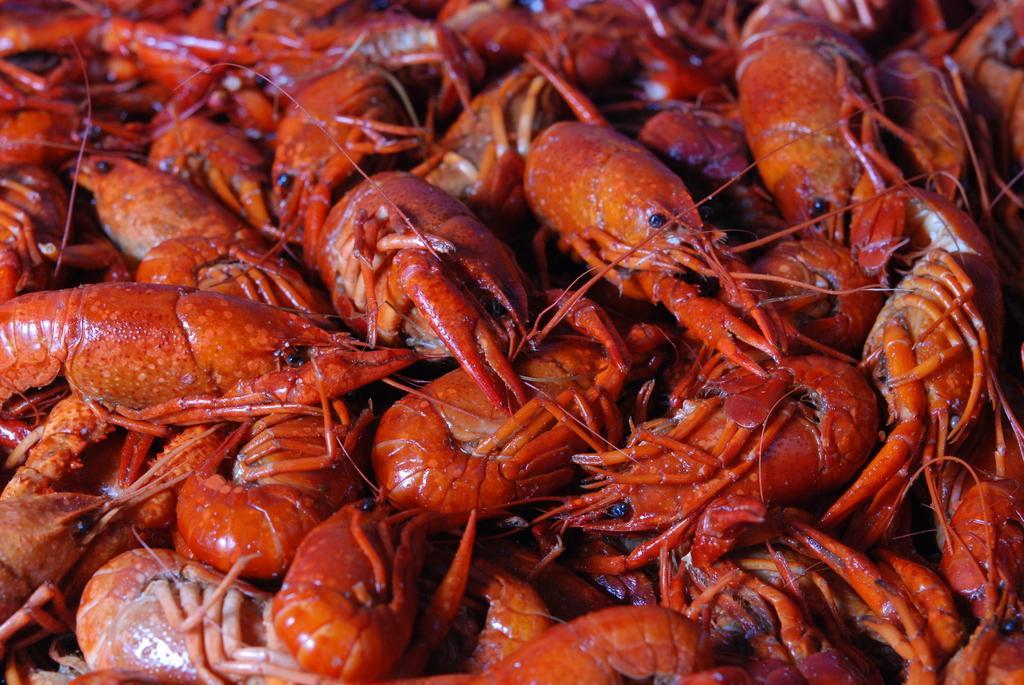In one or two sentences, can you explain what this image depicts? Here in this picture we can see number of shrimps present over a place. 